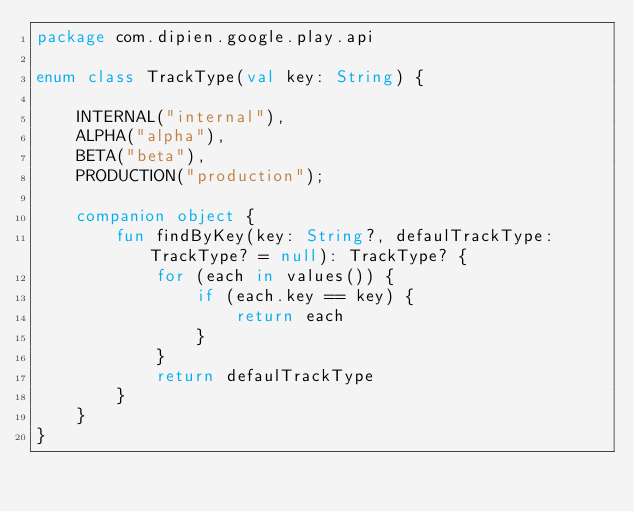Convert code to text. <code><loc_0><loc_0><loc_500><loc_500><_Kotlin_>package com.dipien.google.play.api

enum class TrackType(val key: String) {

    INTERNAL("internal"),
    ALPHA("alpha"),
    BETA("beta"),
    PRODUCTION("production");

    companion object {
        fun findByKey(key: String?, defaulTrackType: TrackType? = null): TrackType? {
            for (each in values()) {
                if (each.key == key) {
                    return each
                }
            }
            return defaulTrackType
        }
    }
}
</code> 